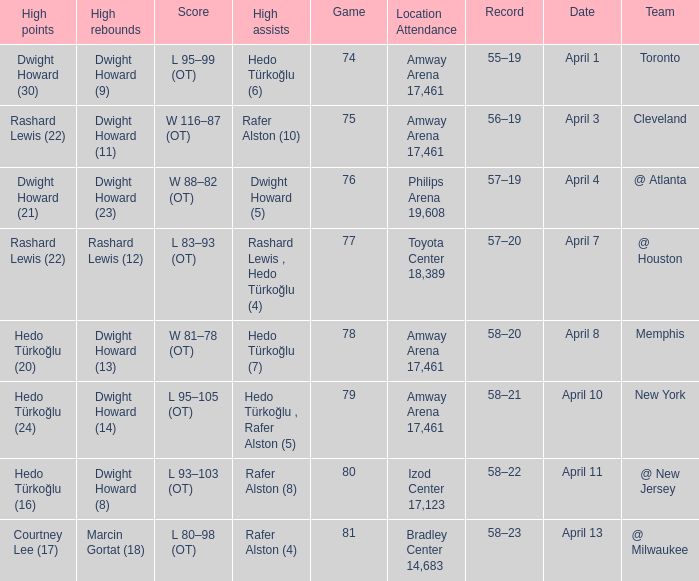Which player had the highest points in game 79? Hedo Türkoğlu (24). 